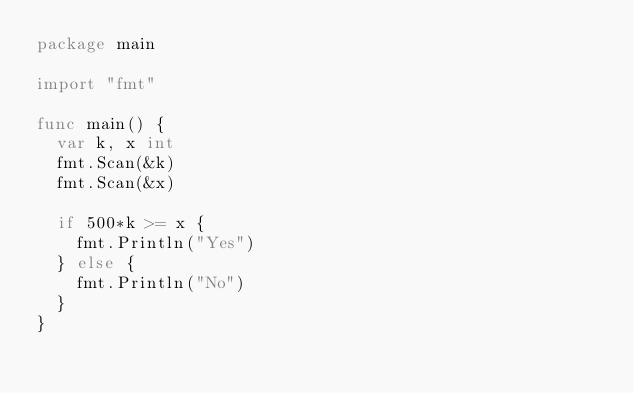<code> <loc_0><loc_0><loc_500><loc_500><_Go_>package main

import "fmt"

func main() {
	var k, x int
	fmt.Scan(&k)
	fmt.Scan(&x)

	if 500*k >= x {
		fmt.Println("Yes")
	} else {
		fmt.Println("No")
	}
}</code> 